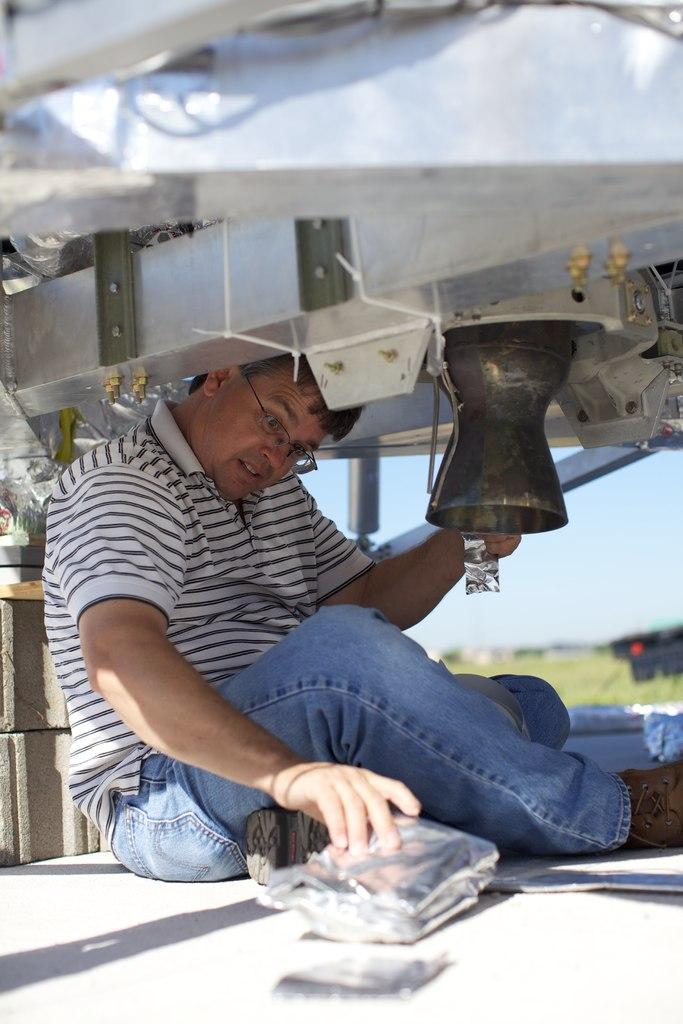What is the main subject of the image? There is a man in the image. What is the man doing in the image? The man is holding some objects and sitting on the ground. What can be seen above the man? There are objects above the man. What type of natural environment is visible behind the man? There is grass visible behind the man. What is visible in the background of the image? The sky is visible in the background of the image. What type of stick can be seen in the man's tongue in the image? There is no stick or tongue visible in the image; the man is holding objects and sitting on the ground. What angle is the man's head tilted at in the image? The angle of the man's head is not mentioned in the provided facts, so it cannot be determined from the image. 